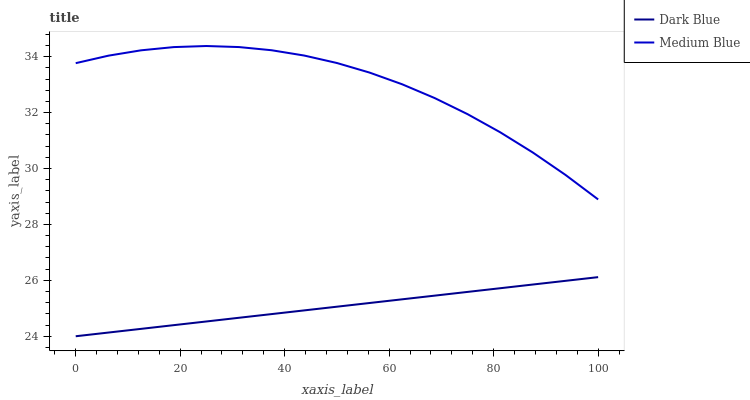Does Medium Blue have the minimum area under the curve?
Answer yes or no. No. Is Medium Blue the smoothest?
Answer yes or no. No. Does Medium Blue have the lowest value?
Answer yes or no. No. Is Dark Blue less than Medium Blue?
Answer yes or no. Yes. Is Medium Blue greater than Dark Blue?
Answer yes or no. Yes. Does Dark Blue intersect Medium Blue?
Answer yes or no. No. 